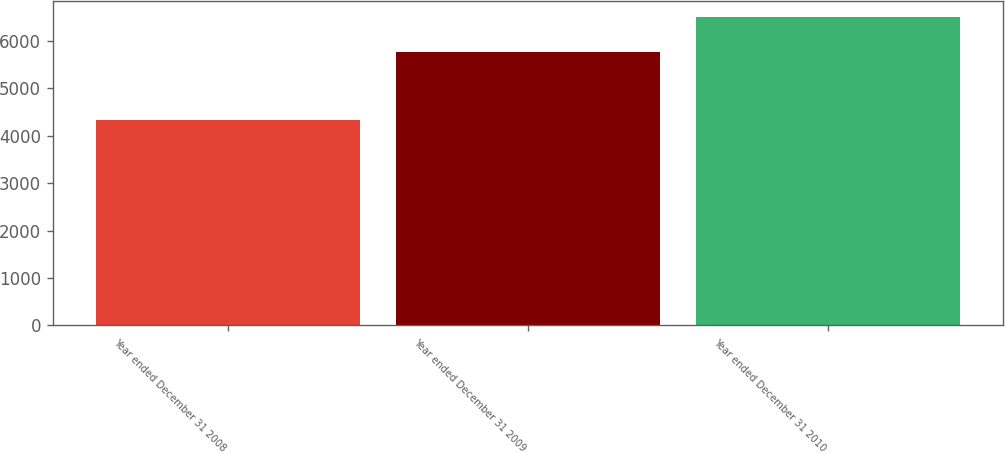Convert chart. <chart><loc_0><loc_0><loc_500><loc_500><bar_chart><fcel>Year ended December 31 2008<fcel>Year ended December 31 2009<fcel>Year ended December 31 2010<nl><fcel>4329<fcel>5757<fcel>6507<nl></chart> 